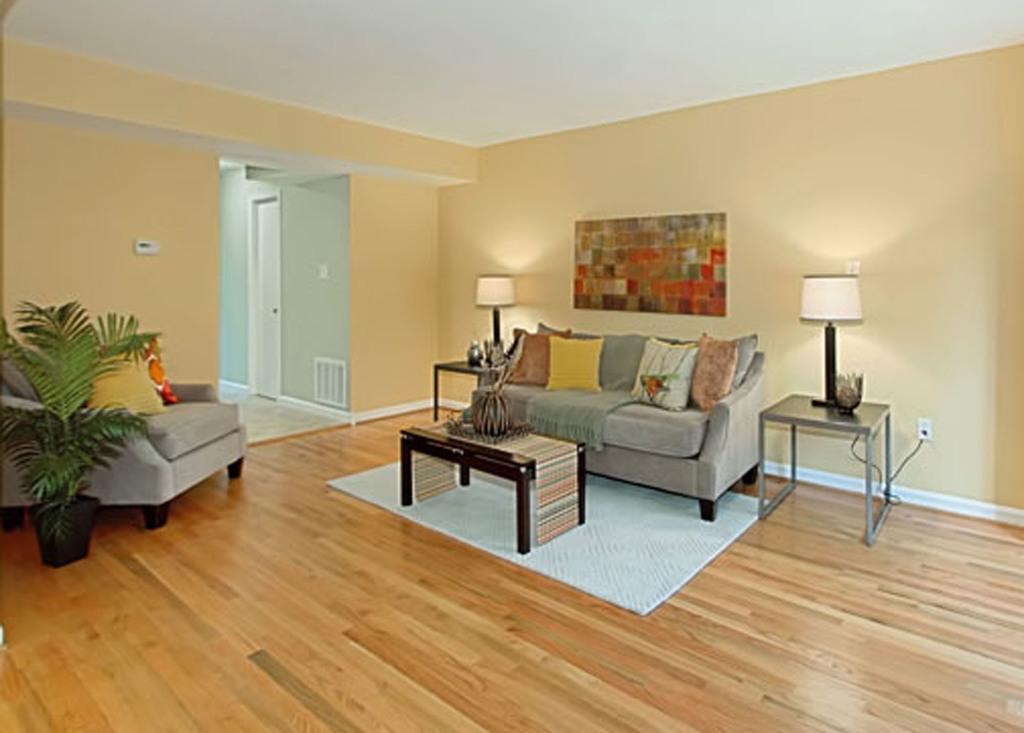Can you describe this image briefly? This picture is of inside the room. In the center there is a couch on the top of which cushions are placed. There is a port placed on the top of the center table and we can see the side lamps placed on the side tables. On the left there is a sofa and a house plant. In the background we can see a wall, a door and picture frame hanging on a wall. 